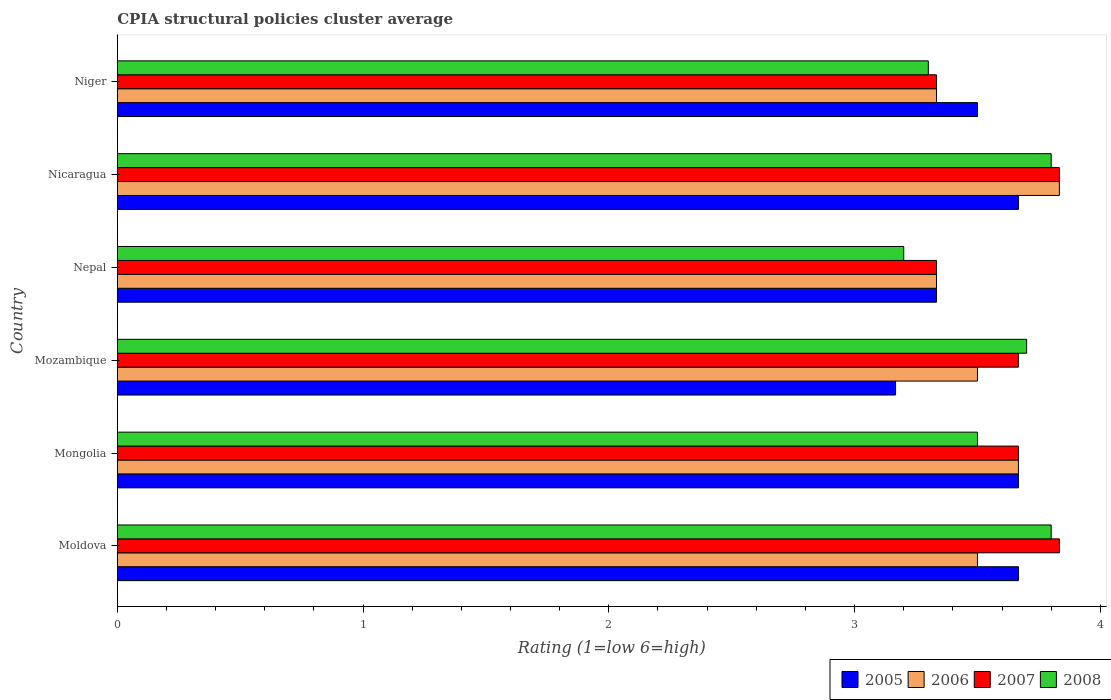How many different coloured bars are there?
Your response must be concise. 4. How many bars are there on the 2nd tick from the top?
Keep it short and to the point. 4. What is the label of the 4th group of bars from the top?
Provide a succinct answer. Mozambique. In how many cases, is the number of bars for a given country not equal to the number of legend labels?
Ensure brevity in your answer.  0. What is the CPIA rating in 2005 in Moldova?
Give a very brief answer. 3.67. Across all countries, what is the maximum CPIA rating in 2006?
Provide a short and direct response. 3.83. Across all countries, what is the minimum CPIA rating in 2005?
Keep it short and to the point. 3.17. In which country was the CPIA rating in 2007 maximum?
Your answer should be very brief. Moldova. In which country was the CPIA rating in 2008 minimum?
Ensure brevity in your answer.  Nepal. What is the total CPIA rating in 2008 in the graph?
Provide a short and direct response. 21.3. What is the difference between the CPIA rating in 2005 in Mongolia and that in Niger?
Your answer should be compact. 0.17. What is the difference between the CPIA rating in 2006 in Moldova and the CPIA rating in 2008 in Nepal?
Your answer should be compact. 0.3. What is the average CPIA rating in 2005 per country?
Your answer should be very brief. 3.5. What is the difference between the CPIA rating in 2006 and CPIA rating in 2007 in Moldova?
Your answer should be compact. -0.33. What is the ratio of the CPIA rating in 2008 in Mozambique to that in Nicaragua?
Your answer should be compact. 0.97. Is the difference between the CPIA rating in 2006 in Moldova and Nepal greater than the difference between the CPIA rating in 2007 in Moldova and Nepal?
Offer a terse response. No. What is the difference between the highest and the lowest CPIA rating in 2007?
Your answer should be compact. 0.5. In how many countries, is the CPIA rating in 2006 greater than the average CPIA rating in 2006 taken over all countries?
Your answer should be very brief. 2. Is the sum of the CPIA rating in 2005 in Mozambique and Nepal greater than the maximum CPIA rating in 2008 across all countries?
Your answer should be very brief. Yes. Is it the case that in every country, the sum of the CPIA rating in 2008 and CPIA rating in 2006 is greater than the sum of CPIA rating in 2005 and CPIA rating in 2007?
Give a very brief answer. No. What does the 4th bar from the top in Mozambique represents?
Provide a short and direct response. 2005. What does the 4th bar from the bottom in Moldova represents?
Your answer should be compact. 2008. Are all the bars in the graph horizontal?
Offer a very short reply. Yes. Does the graph contain grids?
Provide a short and direct response. No. Where does the legend appear in the graph?
Your response must be concise. Bottom right. How many legend labels are there?
Your answer should be very brief. 4. What is the title of the graph?
Make the answer very short. CPIA structural policies cluster average. What is the Rating (1=low 6=high) of 2005 in Moldova?
Your response must be concise. 3.67. What is the Rating (1=low 6=high) in 2006 in Moldova?
Give a very brief answer. 3.5. What is the Rating (1=low 6=high) in 2007 in Moldova?
Provide a succinct answer. 3.83. What is the Rating (1=low 6=high) in 2005 in Mongolia?
Offer a terse response. 3.67. What is the Rating (1=low 6=high) of 2006 in Mongolia?
Your answer should be compact. 3.67. What is the Rating (1=low 6=high) of 2007 in Mongolia?
Ensure brevity in your answer.  3.67. What is the Rating (1=low 6=high) in 2005 in Mozambique?
Make the answer very short. 3.17. What is the Rating (1=low 6=high) of 2006 in Mozambique?
Make the answer very short. 3.5. What is the Rating (1=low 6=high) of 2007 in Mozambique?
Give a very brief answer. 3.67. What is the Rating (1=low 6=high) of 2008 in Mozambique?
Offer a very short reply. 3.7. What is the Rating (1=low 6=high) of 2005 in Nepal?
Your answer should be compact. 3.33. What is the Rating (1=low 6=high) in 2006 in Nepal?
Offer a very short reply. 3.33. What is the Rating (1=low 6=high) of 2007 in Nepal?
Provide a succinct answer. 3.33. What is the Rating (1=low 6=high) in 2005 in Nicaragua?
Provide a succinct answer. 3.67. What is the Rating (1=low 6=high) in 2006 in Nicaragua?
Provide a succinct answer. 3.83. What is the Rating (1=low 6=high) of 2007 in Nicaragua?
Offer a terse response. 3.83. What is the Rating (1=low 6=high) of 2008 in Nicaragua?
Offer a very short reply. 3.8. What is the Rating (1=low 6=high) in 2005 in Niger?
Your answer should be very brief. 3.5. What is the Rating (1=low 6=high) of 2006 in Niger?
Ensure brevity in your answer.  3.33. What is the Rating (1=low 6=high) in 2007 in Niger?
Offer a terse response. 3.33. What is the Rating (1=low 6=high) in 2008 in Niger?
Ensure brevity in your answer.  3.3. Across all countries, what is the maximum Rating (1=low 6=high) of 2005?
Your answer should be very brief. 3.67. Across all countries, what is the maximum Rating (1=low 6=high) in 2006?
Provide a short and direct response. 3.83. Across all countries, what is the maximum Rating (1=low 6=high) of 2007?
Offer a very short reply. 3.83. Across all countries, what is the minimum Rating (1=low 6=high) in 2005?
Provide a succinct answer. 3.17. Across all countries, what is the minimum Rating (1=low 6=high) of 2006?
Give a very brief answer. 3.33. Across all countries, what is the minimum Rating (1=low 6=high) of 2007?
Your answer should be compact. 3.33. What is the total Rating (1=low 6=high) of 2005 in the graph?
Give a very brief answer. 21. What is the total Rating (1=low 6=high) in 2006 in the graph?
Give a very brief answer. 21.17. What is the total Rating (1=low 6=high) in 2007 in the graph?
Keep it short and to the point. 21.67. What is the total Rating (1=low 6=high) of 2008 in the graph?
Give a very brief answer. 21.3. What is the difference between the Rating (1=low 6=high) of 2006 in Moldova and that in Mongolia?
Provide a short and direct response. -0.17. What is the difference between the Rating (1=low 6=high) of 2005 in Moldova and that in Mozambique?
Keep it short and to the point. 0.5. What is the difference between the Rating (1=low 6=high) in 2007 in Moldova and that in Mozambique?
Your answer should be very brief. 0.17. What is the difference between the Rating (1=low 6=high) of 2005 in Moldova and that in Nepal?
Provide a short and direct response. 0.33. What is the difference between the Rating (1=low 6=high) of 2007 in Moldova and that in Nepal?
Provide a succinct answer. 0.5. What is the difference between the Rating (1=low 6=high) of 2008 in Moldova and that in Nepal?
Keep it short and to the point. 0.6. What is the difference between the Rating (1=low 6=high) in 2006 in Moldova and that in Nicaragua?
Your answer should be very brief. -0.33. What is the difference between the Rating (1=low 6=high) in 2007 in Moldova and that in Nicaragua?
Offer a terse response. 0. What is the difference between the Rating (1=low 6=high) of 2005 in Moldova and that in Niger?
Keep it short and to the point. 0.17. What is the difference between the Rating (1=low 6=high) in 2006 in Moldova and that in Niger?
Ensure brevity in your answer.  0.17. What is the difference between the Rating (1=low 6=high) in 2007 in Moldova and that in Niger?
Your response must be concise. 0.5. What is the difference between the Rating (1=low 6=high) of 2008 in Mongolia and that in Mozambique?
Offer a very short reply. -0.2. What is the difference between the Rating (1=low 6=high) of 2005 in Mongolia and that in Nepal?
Keep it short and to the point. 0.33. What is the difference between the Rating (1=low 6=high) in 2008 in Mongolia and that in Nepal?
Your response must be concise. 0.3. What is the difference between the Rating (1=low 6=high) of 2006 in Mongolia and that in Nicaragua?
Ensure brevity in your answer.  -0.17. What is the difference between the Rating (1=low 6=high) of 2008 in Mongolia and that in Nicaragua?
Provide a short and direct response. -0.3. What is the difference between the Rating (1=low 6=high) in 2007 in Mongolia and that in Niger?
Provide a succinct answer. 0.33. What is the difference between the Rating (1=low 6=high) in 2008 in Mongolia and that in Niger?
Provide a short and direct response. 0.2. What is the difference between the Rating (1=low 6=high) of 2006 in Mozambique and that in Nepal?
Your answer should be compact. 0.17. What is the difference between the Rating (1=low 6=high) in 2007 in Mozambique and that in Nepal?
Your answer should be very brief. 0.33. What is the difference between the Rating (1=low 6=high) of 2007 in Mozambique and that in Nicaragua?
Offer a terse response. -0.17. What is the difference between the Rating (1=low 6=high) of 2005 in Mozambique and that in Niger?
Ensure brevity in your answer.  -0.33. What is the difference between the Rating (1=low 6=high) in 2007 in Nepal and that in Nicaragua?
Your response must be concise. -0.5. What is the difference between the Rating (1=low 6=high) in 2007 in Nepal and that in Niger?
Your answer should be very brief. 0. What is the difference between the Rating (1=low 6=high) in 2008 in Nepal and that in Niger?
Your response must be concise. -0.1. What is the difference between the Rating (1=low 6=high) in 2006 in Nicaragua and that in Niger?
Give a very brief answer. 0.5. What is the difference between the Rating (1=low 6=high) in 2008 in Nicaragua and that in Niger?
Your answer should be compact. 0.5. What is the difference between the Rating (1=low 6=high) of 2005 in Moldova and the Rating (1=low 6=high) of 2006 in Mongolia?
Give a very brief answer. 0. What is the difference between the Rating (1=low 6=high) of 2006 in Moldova and the Rating (1=low 6=high) of 2007 in Mongolia?
Your answer should be compact. -0.17. What is the difference between the Rating (1=low 6=high) of 2007 in Moldova and the Rating (1=low 6=high) of 2008 in Mongolia?
Your answer should be compact. 0.33. What is the difference between the Rating (1=low 6=high) in 2005 in Moldova and the Rating (1=low 6=high) in 2006 in Mozambique?
Keep it short and to the point. 0.17. What is the difference between the Rating (1=low 6=high) of 2005 in Moldova and the Rating (1=low 6=high) of 2008 in Mozambique?
Keep it short and to the point. -0.03. What is the difference between the Rating (1=low 6=high) of 2006 in Moldova and the Rating (1=low 6=high) of 2008 in Mozambique?
Provide a short and direct response. -0.2. What is the difference between the Rating (1=low 6=high) of 2007 in Moldova and the Rating (1=low 6=high) of 2008 in Mozambique?
Offer a very short reply. 0.13. What is the difference between the Rating (1=low 6=high) in 2005 in Moldova and the Rating (1=low 6=high) in 2008 in Nepal?
Provide a succinct answer. 0.47. What is the difference between the Rating (1=low 6=high) of 2007 in Moldova and the Rating (1=low 6=high) of 2008 in Nepal?
Your answer should be compact. 0.63. What is the difference between the Rating (1=low 6=high) of 2005 in Moldova and the Rating (1=low 6=high) of 2007 in Nicaragua?
Provide a succinct answer. -0.17. What is the difference between the Rating (1=low 6=high) in 2005 in Moldova and the Rating (1=low 6=high) in 2008 in Nicaragua?
Your answer should be compact. -0.13. What is the difference between the Rating (1=low 6=high) in 2006 in Moldova and the Rating (1=low 6=high) in 2007 in Nicaragua?
Your response must be concise. -0.33. What is the difference between the Rating (1=low 6=high) of 2005 in Moldova and the Rating (1=low 6=high) of 2006 in Niger?
Make the answer very short. 0.33. What is the difference between the Rating (1=low 6=high) of 2005 in Moldova and the Rating (1=low 6=high) of 2007 in Niger?
Your answer should be very brief. 0.33. What is the difference between the Rating (1=low 6=high) in 2005 in Moldova and the Rating (1=low 6=high) in 2008 in Niger?
Your answer should be very brief. 0.37. What is the difference between the Rating (1=low 6=high) of 2006 in Moldova and the Rating (1=low 6=high) of 2007 in Niger?
Give a very brief answer. 0.17. What is the difference between the Rating (1=low 6=high) in 2007 in Moldova and the Rating (1=low 6=high) in 2008 in Niger?
Give a very brief answer. 0.53. What is the difference between the Rating (1=low 6=high) of 2005 in Mongolia and the Rating (1=low 6=high) of 2006 in Mozambique?
Give a very brief answer. 0.17. What is the difference between the Rating (1=low 6=high) in 2005 in Mongolia and the Rating (1=low 6=high) in 2007 in Mozambique?
Your response must be concise. 0. What is the difference between the Rating (1=low 6=high) of 2005 in Mongolia and the Rating (1=low 6=high) of 2008 in Mozambique?
Offer a terse response. -0.03. What is the difference between the Rating (1=low 6=high) in 2006 in Mongolia and the Rating (1=low 6=high) in 2007 in Mozambique?
Give a very brief answer. 0. What is the difference between the Rating (1=low 6=high) of 2006 in Mongolia and the Rating (1=low 6=high) of 2008 in Mozambique?
Make the answer very short. -0.03. What is the difference between the Rating (1=low 6=high) in 2007 in Mongolia and the Rating (1=low 6=high) in 2008 in Mozambique?
Your answer should be compact. -0.03. What is the difference between the Rating (1=low 6=high) of 2005 in Mongolia and the Rating (1=low 6=high) of 2006 in Nepal?
Your answer should be compact. 0.33. What is the difference between the Rating (1=low 6=high) of 2005 in Mongolia and the Rating (1=low 6=high) of 2007 in Nepal?
Your answer should be very brief. 0.33. What is the difference between the Rating (1=low 6=high) of 2005 in Mongolia and the Rating (1=low 6=high) of 2008 in Nepal?
Keep it short and to the point. 0.47. What is the difference between the Rating (1=low 6=high) of 2006 in Mongolia and the Rating (1=low 6=high) of 2007 in Nepal?
Your answer should be compact. 0.33. What is the difference between the Rating (1=low 6=high) of 2006 in Mongolia and the Rating (1=low 6=high) of 2008 in Nepal?
Keep it short and to the point. 0.47. What is the difference between the Rating (1=low 6=high) in 2007 in Mongolia and the Rating (1=low 6=high) in 2008 in Nepal?
Make the answer very short. 0.47. What is the difference between the Rating (1=low 6=high) of 2005 in Mongolia and the Rating (1=low 6=high) of 2007 in Nicaragua?
Provide a succinct answer. -0.17. What is the difference between the Rating (1=low 6=high) in 2005 in Mongolia and the Rating (1=low 6=high) in 2008 in Nicaragua?
Keep it short and to the point. -0.13. What is the difference between the Rating (1=low 6=high) in 2006 in Mongolia and the Rating (1=low 6=high) in 2008 in Nicaragua?
Offer a very short reply. -0.13. What is the difference between the Rating (1=low 6=high) of 2007 in Mongolia and the Rating (1=low 6=high) of 2008 in Nicaragua?
Make the answer very short. -0.13. What is the difference between the Rating (1=low 6=high) in 2005 in Mongolia and the Rating (1=low 6=high) in 2008 in Niger?
Your answer should be compact. 0.37. What is the difference between the Rating (1=low 6=high) in 2006 in Mongolia and the Rating (1=low 6=high) in 2008 in Niger?
Your answer should be compact. 0.37. What is the difference between the Rating (1=low 6=high) in 2007 in Mongolia and the Rating (1=low 6=high) in 2008 in Niger?
Your answer should be compact. 0.37. What is the difference between the Rating (1=low 6=high) of 2005 in Mozambique and the Rating (1=low 6=high) of 2006 in Nepal?
Give a very brief answer. -0.17. What is the difference between the Rating (1=low 6=high) in 2005 in Mozambique and the Rating (1=low 6=high) in 2007 in Nepal?
Your response must be concise. -0.17. What is the difference between the Rating (1=low 6=high) in 2005 in Mozambique and the Rating (1=low 6=high) in 2008 in Nepal?
Your answer should be very brief. -0.03. What is the difference between the Rating (1=low 6=high) in 2006 in Mozambique and the Rating (1=low 6=high) in 2007 in Nepal?
Provide a short and direct response. 0.17. What is the difference between the Rating (1=low 6=high) of 2006 in Mozambique and the Rating (1=low 6=high) of 2008 in Nepal?
Provide a short and direct response. 0.3. What is the difference between the Rating (1=low 6=high) in 2007 in Mozambique and the Rating (1=low 6=high) in 2008 in Nepal?
Ensure brevity in your answer.  0.47. What is the difference between the Rating (1=low 6=high) of 2005 in Mozambique and the Rating (1=low 6=high) of 2008 in Nicaragua?
Offer a very short reply. -0.63. What is the difference between the Rating (1=low 6=high) of 2006 in Mozambique and the Rating (1=low 6=high) of 2007 in Nicaragua?
Offer a very short reply. -0.33. What is the difference between the Rating (1=low 6=high) of 2006 in Mozambique and the Rating (1=low 6=high) of 2008 in Nicaragua?
Your response must be concise. -0.3. What is the difference between the Rating (1=low 6=high) in 2007 in Mozambique and the Rating (1=low 6=high) in 2008 in Nicaragua?
Provide a succinct answer. -0.13. What is the difference between the Rating (1=low 6=high) of 2005 in Mozambique and the Rating (1=low 6=high) of 2007 in Niger?
Your response must be concise. -0.17. What is the difference between the Rating (1=low 6=high) of 2005 in Mozambique and the Rating (1=low 6=high) of 2008 in Niger?
Offer a very short reply. -0.13. What is the difference between the Rating (1=low 6=high) in 2006 in Mozambique and the Rating (1=low 6=high) in 2008 in Niger?
Your response must be concise. 0.2. What is the difference between the Rating (1=low 6=high) of 2007 in Mozambique and the Rating (1=low 6=high) of 2008 in Niger?
Offer a terse response. 0.37. What is the difference between the Rating (1=low 6=high) in 2005 in Nepal and the Rating (1=low 6=high) in 2007 in Nicaragua?
Your answer should be very brief. -0.5. What is the difference between the Rating (1=low 6=high) of 2005 in Nepal and the Rating (1=low 6=high) of 2008 in Nicaragua?
Give a very brief answer. -0.47. What is the difference between the Rating (1=low 6=high) of 2006 in Nepal and the Rating (1=low 6=high) of 2008 in Nicaragua?
Your answer should be very brief. -0.47. What is the difference between the Rating (1=low 6=high) in 2007 in Nepal and the Rating (1=low 6=high) in 2008 in Nicaragua?
Ensure brevity in your answer.  -0.47. What is the difference between the Rating (1=low 6=high) in 2005 in Nepal and the Rating (1=low 6=high) in 2006 in Niger?
Your answer should be very brief. 0. What is the difference between the Rating (1=low 6=high) of 2005 in Nepal and the Rating (1=low 6=high) of 2007 in Niger?
Keep it short and to the point. 0. What is the difference between the Rating (1=low 6=high) in 2006 in Nepal and the Rating (1=low 6=high) in 2008 in Niger?
Your answer should be very brief. 0.03. What is the difference between the Rating (1=low 6=high) in 2005 in Nicaragua and the Rating (1=low 6=high) in 2006 in Niger?
Provide a short and direct response. 0.33. What is the difference between the Rating (1=low 6=high) in 2005 in Nicaragua and the Rating (1=low 6=high) in 2007 in Niger?
Your answer should be compact. 0.33. What is the difference between the Rating (1=low 6=high) in 2005 in Nicaragua and the Rating (1=low 6=high) in 2008 in Niger?
Offer a terse response. 0.37. What is the difference between the Rating (1=low 6=high) in 2006 in Nicaragua and the Rating (1=low 6=high) in 2008 in Niger?
Your answer should be very brief. 0.53. What is the difference between the Rating (1=low 6=high) in 2007 in Nicaragua and the Rating (1=low 6=high) in 2008 in Niger?
Your answer should be very brief. 0.53. What is the average Rating (1=low 6=high) of 2005 per country?
Your response must be concise. 3.5. What is the average Rating (1=low 6=high) in 2006 per country?
Provide a short and direct response. 3.53. What is the average Rating (1=low 6=high) of 2007 per country?
Your response must be concise. 3.61. What is the average Rating (1=low 6=high) of 2008 per country?
Ensure brevity in your answer.  3.55. What is the difference between the Rating (1=low 6=high) of 2005 and Rating (1=low 6=high) of 2007 in Moldova?
Ensure brevity in your answer.  -0.17. What is the difference between the Rating (1=low 6=high) in 2005 and Rating (1=low 6=high) in 2008 in Moldova?
Your answer should be very brief. -0.13. What is the difference between the Rating (1=low 6=high) in 2006 and Rating (1=low 6=high) in 2008 in Moldova?
Provide a short and direct response. -0.3. What is the difference between the Rating (1=low 6=high) of 2005 and Rating (1=low 6=high) of 2006 in Mongolia?
Ensure brevity in your answer.  0. What is the difference between the Rating (1=low 6=high) of 2005 and Rating (1=low 6=high) of 2007 in Mongolia?
Offer a very short reply. 0. What is the difference between the Rating (1=low 6=high) of 2006 and Rating (1=low 6=high) of 2008 in Mongolia?
Ensure brevity in your answer.  0.17. What is the difference between the Rating (1=low 6=high) of 2007 and Rating (1=low 6=high) of 2008 in Mongolia?
Your answer should be very brief. 0.17. What is the difference between the Rating (1=low 6=high) in 2005 and Rating (1=low 6=high) in 2008 in Mozambique?
Offer a terse response. -0.53. What is the difference between the Rating (1=low 6=high) in 2006 and Rating (1=low 6=high) in 2007 in Mozambique?
Offer a terse response. -0.17. What is the difference between the Rating (1=low 6=high) of 2006 and Rating (1=low 6=high) of 2008 in Mozambique?
Offer a terse response. -0.2. What is the difference between the Rating (1=low 6=high) in 2007 and Rating (1=low 6=high) in 2008 in Mozambique?
Your response must be concise. -0.03. What is the difference between the Rating (1=low 6=high) in 2005 and Rating (1=low 6=high) in 2007 in Nepal?
Provide a succinct answer. 0. What is the difference between the Rating (1=low 6=high) of 2005 and Rating (1=low 6=high) of 2008 in Nepal?
Your response must be concise. 0.13. What is the difference between the Rating (1=low 6=high) in 2006 and Rating (1=low 6=high) in 2007 in Nepal?
Your answer should be compact. 0. What is the difference between the Rating (1=low 6=high) in 2006 and Rating (1=low 6=high) in 2008 in Nepal?
Provide a short and direct response. 0.13. What is the difference between the Rating (1=low 6=high) in 2007 and Rating (1=low 6=high) in 2008 in Nepal?
Keep it short and to the point. 0.13. What is the difference between the Rating (1=low 6=high) in 2005 and Rating (1=low 6=high) in 2007 in Nicaragua?
Ensure brevity in your answer.  -0.17. What is the difference between the Rating (1=low 6=high) of 2005 and Rating (1=low 6=high) of 2008 in Nicaragua?
Offer a very short reply. -0.13. What is the difference between the Rating (1=low 6=high) of 2006 and Rating (1=low 6=high) of 2008 in Nicaragua?
Your answer should be compact. 0.03. What is the difference between the Rating (1=low 6=high) in 2005 and Rating (1=low 6=high) in 2006 in Niger?
Ensure brevity in your answer.  0.17. What is the difference between the Rating (1=low 6=high) in 2005 and Rating (1=low 6=high) in 2007 in Niger?
Make the answer very short. 0.17. What is the difference between the Rating (1=low 6=high) of 2005 and Rating (1=low 6=high) of 2008 in Niger?
Your answer should be very brief. 0.2. What is the difference between the Rating (1=low 6=high) in 2006 and Rating (1=low 6=high) in 2008 in Niger?
Make the answer very short. 0.03. What is the difference between the Rating (1=low 6=high) in 2007 and Rating (1=low 6=high) in 2008 in Niger?
Give a very brief answer. 0.03. What is the ratio of the Rating (1=low 6=high) in 2005 in Moldova to that in Mongolia?
Your answer should be very brief. 1. What is the ratio of the Rating (1=low 6=high) in 2006 in Moldova to that in Mongolia?
Offer a terse response. 0.95. What is the ratio of the Rating (1=low 6=high) in 2007 in Moldova to that in Mongolia?
Your answer should be very brief. 1.05. What is the ratio of the Rating (1=low 6=high) of 2008 in Moldova to that in Mongolia?
Your answer should be compact. 1.09. What is the ratio of the Rating (1=low 6=high) in 2005 in Moldova to that in Mozambique?
Your answer should be very brief. 1.16. What is the ratio of the Rating (1=low 6=high) of 2007 in Moldova to that in Mozambique?
Ensure brevity in your answer.  1.05. What is the ratio of the Rating (1=low 6=high) in 2007 in Moldova to that in Nepal?
Your answer should be very brief. 1.15. What is the ratio of the Rating (1=low 6=high) in 2008 in Moldova to that in Nepal?
Your answer should be compact. 1.19. What is the ratio of the Rating (1=low 6=high) in 2008 in Moldova to that in Nicaragua?
Keep it short and to the point. 1. What is the ratio of the Rating (1=low 6=high) in 2005 in Moldova to that in Niger?
Your response must be concise. 1.05. What is the ratio of the Rating (1=low 6=high) of 2007 in Moldova to that in Niger?
Your answer should be compact. 1.15. What is the ratio of the Rating (1=low 6=high) in 2008 in Moldova to that in Niger?
Your answer should be compact. 1.15. What is the ratio of the Rating (1=low 6=high) in 2005 in Mongolia to that in Mozambique?
Provide a succinct answer. 1.16. What is the ratio of the Rating (1=low 6=high) of 2006 in Mongolia to that in Mozambique?
Keep it short and to the point. 1.05. What is the ratio of the Rating (1=low 6=high) of 2008 in Mongolia to that in Mozambique?
Your answer should be compact. 0.95. What is the ratio of the Rating (1=low 6=high) in 2005 in Mongolia to that in Nepal?
Make the answer very short. 1.1. What is the ratio of the Rating (1=low 6=high) of 2007 in Mongolia to that in Nepal?
Offer a very short reply. 1.1. What is the ratio of the Rating (1=low 6=high) of 2008 in Mongolia to that in Nepal?
Provide a short and direct response. 1.09. What is the ratio of the Rating (1=low 6=high) of 2005 in Mongolia to that in Nicaragua?
Keep it short and to the point. 1. What is the ratio of the Rating (1=low 6=high) of 2006 in Mongolia to that in Nicaragua?
Keep it short and to the point. 0.96. What is the ratio of the Rating (1=low 6=high) of 2007 in Mongolia to that in Nicaragua?
Provide a succinct answer. 0.96. What is the ratio of the Rating (1=low 6=high) in 2008 in Mongolia to that in Nicaragua?
Keep it short and to the point. 0.92. What is the ratio of the Rating (1=low 6=high) in 2005 in Mongolia to that in Niger?
Your answer should be very brief. 1.05. What is the ratio of the Rating (1=low 6=high) of 2008 in Mongolia to that in Niger?
Offer a very short reply. 1.06. What is the ratio of the Rating (1=low 6=high) in 2008 in Mozambique to that in Nepal?
Ensure brevity in your answer.  1.16. What is the ratio of the Rating (1=low 6=high) in 2005 in Mozambique to that in Nicaragua?
Give a very brief answer. 0.86. What is the ratio of the Rating (1=low 6=high) in 2006 in Mozambique to that in Nicaragua?
Provide a succinct answer. 0.91. What is the ratio of the Rating (1=low 6=high) of 2007 in Mozambique to that in Nicaragua?
Your answer should be very brief. 0.96. What is the ratio of the Rating (1=low 6=high) of 2008 in Mozambique to that in Nicaragua?
Your response must be concise. 0.97. What is the ratio of the Rating (1=low 6=high) in 2005 in Mozambique to that in Niger?
Provide a succinct answer. 0.9. What is the ratio of the Rating (1=low 6=high) of 2008 in Mozambique to that in Niger?
Ensure brevity in your answer.  1.12. What is the ratio of the Rating (1=low 6=high) of 2006 in Nepal to that in Nicaragua?
Offer a very short reply. 0.87. What is the ratio of the Rating (1=low 6=high) in 2007 in Nepal to that in Nicaragua?
Give a very brief answer. 0.87. What is the ratio of the Rating (1=low 6=high) in 2008 in Nepal to that in Nicaragua?
Your response must be concise. 0.84. What is the ratio of the Rating (1=low 6=high) in 2006 in Nepal to that in Niger?
Make the answer very short. 1. What is the ratio of the Rating (1=low 6=high) in 2007 in Nepal to that in Niger?
Ensure brevity in your answer.  1. What is the ratio of the Rating (1=low 6=high) in 2008 in Nepal to that in Niger?
Provide a short and direct response. 0.97. What is the ratio of the Rating (1=low 6=high) of 2005 in Nicaragua to that in Niger?
Make the answer very short. 1.05. What is the ratio of the Rating (1=low 6=high) in 2006 in Nicaragua to that in Niger?
Provide a succinct answer. 1.15. What is the ratio of the Rating (1=low 6=high) of 2007 in Nicaragua to that in Niger?
Ensure brevity in your answer.  1.15. What is the ratio of the Rating (1=low 6=high) of 2008 in Nicaragua to that in Niger?
Keep it short and to the point. 1.15. What is the difference between the highest and the second highest Rating (1=low 6=high) of 2005?
Give a very brief answer. 0. What is the difference between the highest and the second highest Rating (1=low 6=high) in 2007?
Keep it short and to the point. 0. What is the difference between the highest and the second highest Rating (1=low 6=high) of 2008?
Your answer should be compact. 0. What is the difference between the highest and the lowest Rating (1=low 6=high) of 2005?
Your answer should be compact. 0.5. What is the difference between the highest and the lowest Rating (1=low 6=high) of 2007?
Offer a terse response. 0.5. 